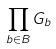Convert formula to latex. <formula><loc_0><loc_0><loc_500><loc_500>\prod _ { b \in B } G _ { b }</formula> 